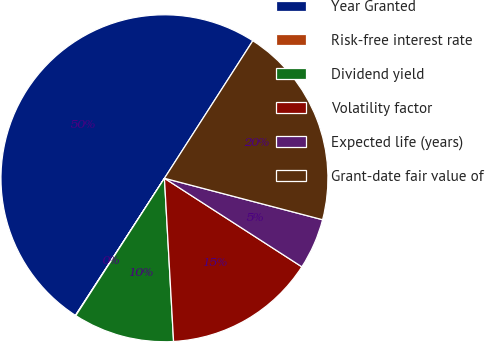Convert chart. <chart><loc_0><loc_0><loc_500><loc_500><pie_chart><fcel>Year Granted<fcel>Risk-free interest rate<fcel>Dividend yield<fcel>Volatility factor<fcel>Expected life (years)<fcel>Grant-date fair value of<nl><fcel>49.93%<fcel>0.04%<fcel>10.01%<fcel>15.0%<fcel>5.03%<fcel>19.99%<nl></chart> 